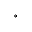Convert formula to latex. <formula><loc_0><loc_0><loc_500><loc_500>^ { \circ }</formula> 